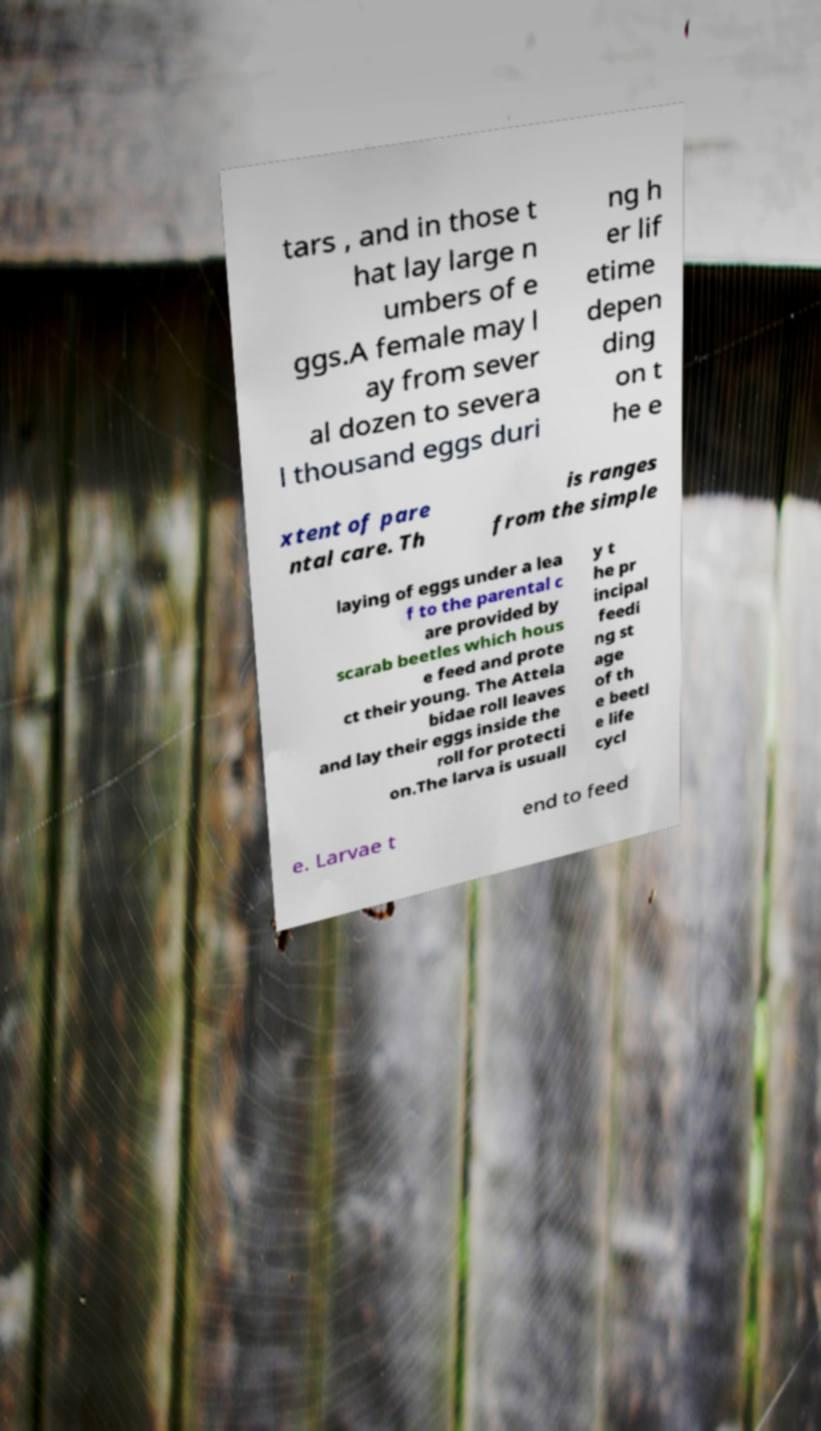What messages or text are displayed in this image? I need them in a readable, typed format. tars , and in those t hat lay large n umbers of e ggs.A female may l ay from sever al dozen to severa l thousand eggs duri ng h er lif etime depen ding on t he e xtent of pare ntal care. Th is ranges from the simple laying of eggs under a lea f to the parental c are provided by scarab beetles which hous e feed and prote ct their young. The Attela bidae roll leaves and lay their eggs inside the roll for protecti on.The larva is usuall y t he pr incipal feedi ng st age of th e beetl e life cycl e. Larvae t end to feed 